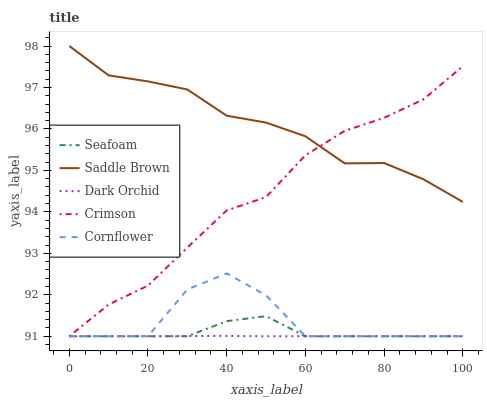Does Dark Orchid have the minimum area under the curve?
Answer yes or no. Yes. Does Saddle Brown have the maximum area under the curve?
Answer yes or no. Yes. Does Cornflower have the minimum area under the curve?
Answer yes or no. No. Does Cornflower have the maximum area under the curve?
Answer yes or no. No. Is Dark Orchid the smoothest?
Answer yes or no. Yes. Is Cornflower the roughest?
Answer yes or no. Yes. Is Seafoam the smoothest?
Answer yes or no. No. Is Seafoam the roughest?
Answer yes or no. No. Does Crimson have the lowest value?
Answer yes or no. Yes. Does Saddle Brown have the lowest value?
Answer yes or no. No. Does Saddle Brown have the highest value?
Answer yes or no. Yes. Does Cornflower have the highest value?
Answer yes or no. No. Is Cornflower less than Saddle Brown?
Answer yes or no. Yes. Is Saddle Brown greater than Cornflower?
Answer yes or no. Yes. Does Cornflower intersect Crimson?
Answer yes or no. Yes. Is Cornflower less than Crimson?
Answer yes or no. No. Is Cornflower greater than Crimson?
Answer yes or no. No. Does Cornflower intersect Saddle Brown?
Answer yes or no. No. 